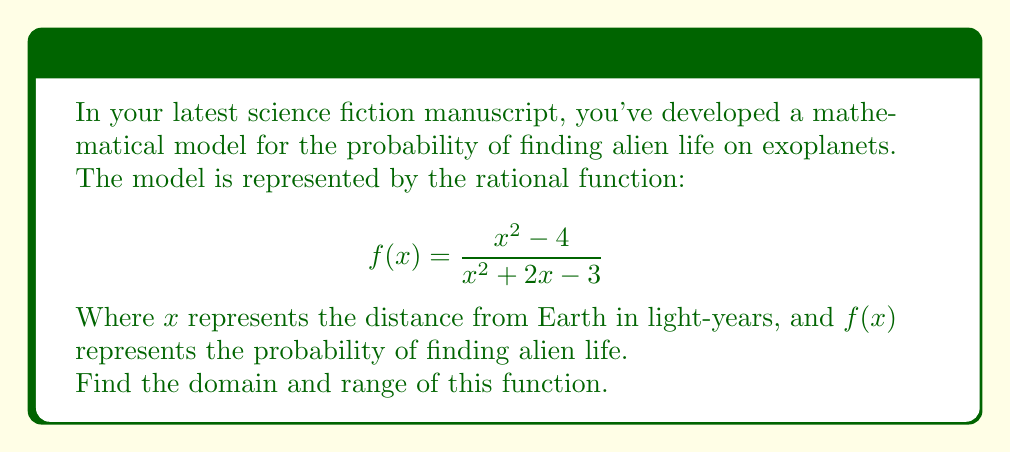Could you help me with this problem? To find the domain and range of this rational function, we'll follow these steps:

1. Domain:
   The domain consists of all real numbers except those that make the denominator zero.
   Set the denominator equal to zero and solve:
   $$x^2 + 2x - 3 = 0$$
   $$(x + 3)(x - 1) = 0$$
   $$x = -3 \text{ or } x = 1$$
   
   Therefore, the domain is all real numbers except -3 and 1.

2. Range:
   To find the range, we'll rewrite the function in the form of $y = f(x)$:
   $$y = \frac{x^2 - 4}{x^2 + 2x - 3}$$
   
   Multiply both sides by the denominator:
   $$y(x^2 + 2x - 3) = x^2 - 4$$
   
   Expand:
   $$yx^2 + 2yx - 3y = x^2 - 4$$
   
   Rearrange to standard form:
   $$x^2(y - 1) + 2yx + (-3y + 4) = 0$$
   
   For this to be a perfect square in terms of x, the discriminant must be zero:
   $$(2y)^2 - 4(y-1)(-3y+4) = 0$$
   
   Simplify:
   $$4y^2 - 4(y^2-y-3y+4) = 0$$
   $$4y^2 - 4y^2 + 16y - 16 = 0$$
   $$16y - 16 = 0$$
   $$y = 1$$
   
   This means the horizontal asymptote is at y = 1.
   
   As $x$ approaches infinity or negative infinity, $f(x)$ approaches 1.
   The function can take values less than 1 and greater than 1, but never equal to 1.

Therefore, the range is all real numbers except 1.
Answer: Domain: $\{x \in \mathbb{R} : x \neq -3 \text{ and } x \neq 1\}$
Range: $\{y \in \mathbb{R} : y \neq 1\}$ 